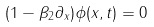<formula> <loc_0><loc_0><loc_500><loc_500>( 1 - \beta _ { 2 } \partial _ { x } ) \phi ( x , t ) = 0</formula> 